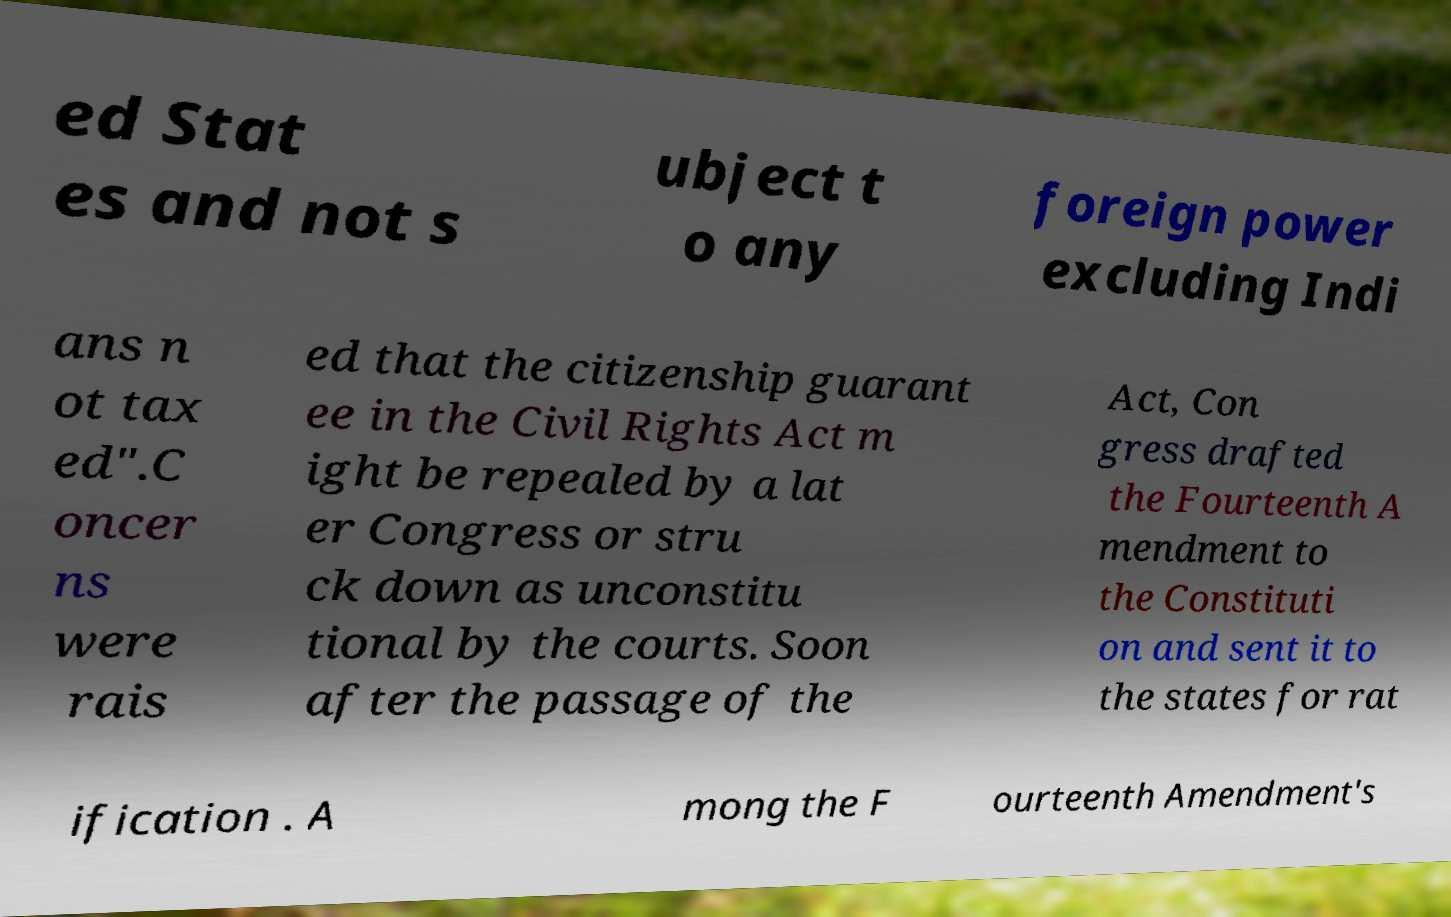Could you assist in decoding the text presented in this image and type it out clearly? ed Stat es and not s ubject t o any foreign power excluding Indi ans n ot tax ed".C oncer ns were rais ed that the citizenship guarant ee in the Civil Rights Act m ight be repealed by a lat er Congress or stru ck down as unconstitu tional by the courts. Soon after the passage of the Act, Con gress drafted the Fourteenth A mendment to the Constituti on and sent it to the states for rat ification . A mong the F ourteenth Amendment's 